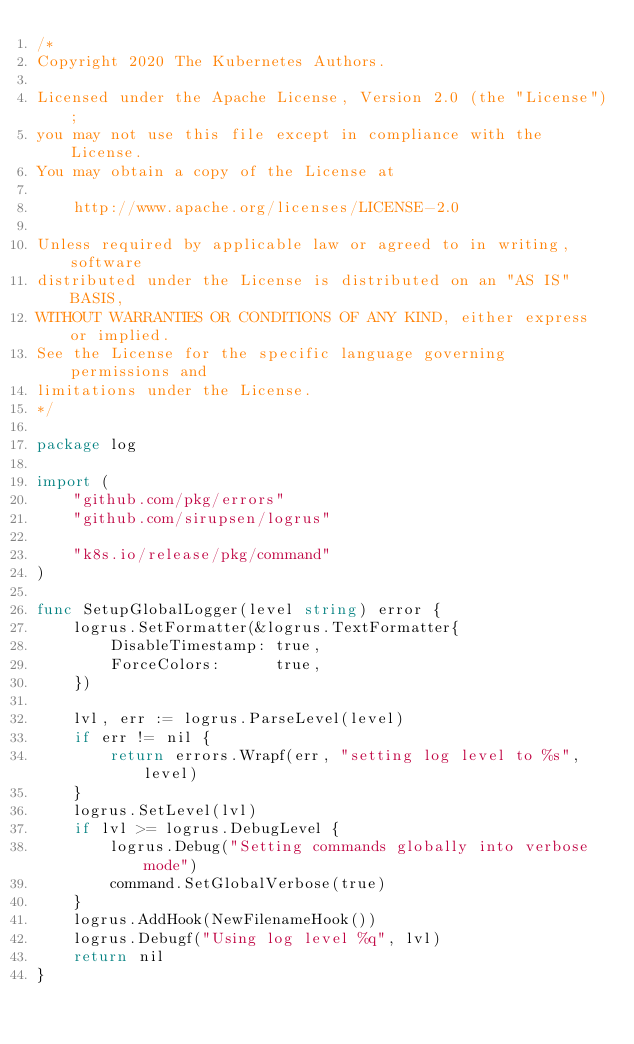Convert code to text. <code><loc_0><loc_0><loc_500><loc_500><_Go_>/*
Copyright 2020 The Kubernetes Authors.

Licensed under the Apache License, Version 2.0 (the "License");
you may not use this file except in compliance with the License.
You may obtain a copy of the License at

    http://www.apache.org/licenses/LICENSE-2.0

Unless required by applicable law or agreed to in writing, software
distributed under the License is distributed on an "AS IS" BASIS,
WITHOUT WARRANTIES OR CONDITIONS OF ANY KIND, either express or implied.
See the License for the specific language governing permissions and
limitations under the License.
*/

package log

import (
	"github.com/pkg/errors"
	"github.com/sirupsen/logrus"

	"k8s.io/release/pkg/command"
)

func SetupGlobalLogger(level string) error {
	logrus.SetFormatter(&logrus.TextFormatter{
		DisableTimestamp: true,
		ForceColors:      true,
	})

	lvl, err := logrus.ParseLevel(level)
	if err != nil {
		return errors.Wrapf(err, "setting log level to %s", level)
	}
	logrus.SetLevel(lvl)
	if lvl >= logrus.DebugLevel {
		logrus.Debug("Setting commands globally into verbose mode")
		command.SetGlobalVerbose(true)
	}
	logrus.AddHook(NewFilenameHook())
	logrus.Debugf("Using log level %q", lvl)
	return nil
}
</code> 